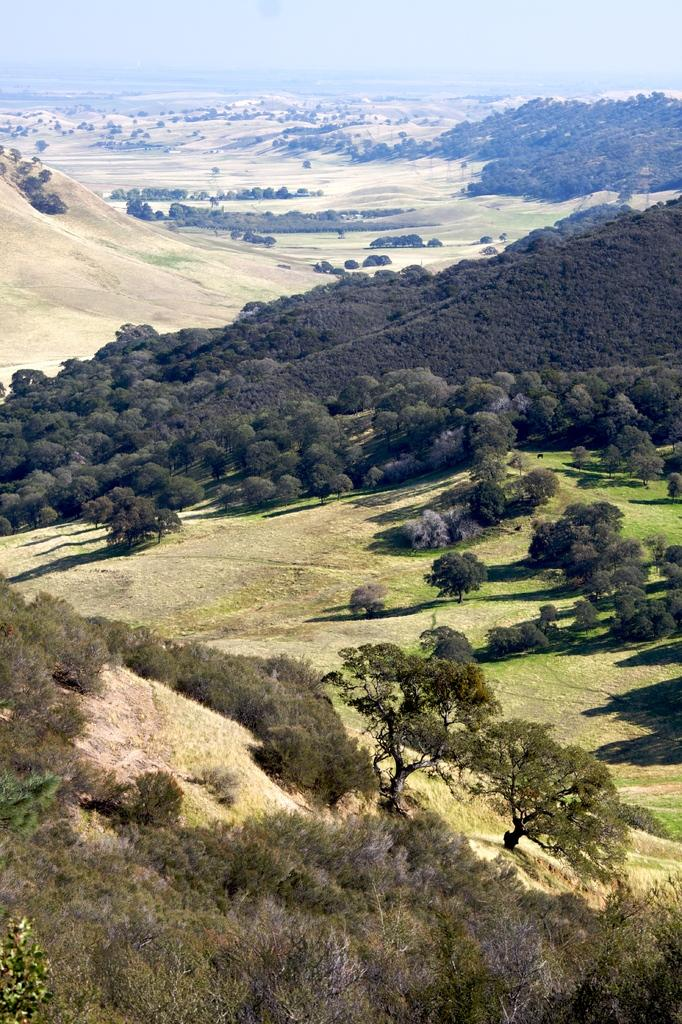What type of vegetation can be seen in the image? There are trees in the image. What geographical features are present in the image? There are hills in the image. What can be seen in the background of the image? The sky is visible in the background of the image. How many family members are visible in the image? There are no family members present in the image; it features trees, hills, and the sky. What type of kitten can be seen playing with a finger in the image? There is no kitten or finger present in the image. 